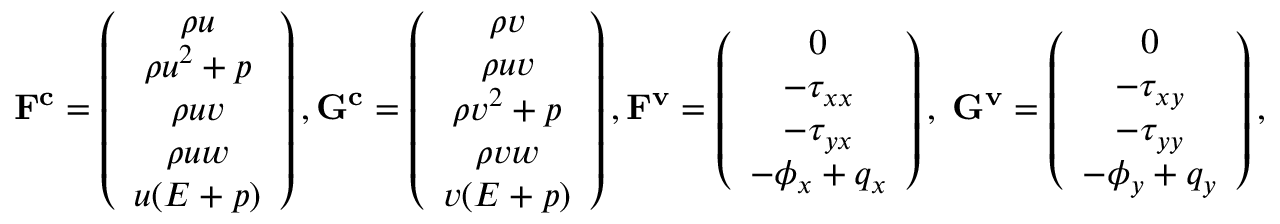<formula> <loc_0><loc_0><loc_500><loc_500>F ^ { c } = \left ( \begin{array} { c } { \rho u } \\ { \rho u ^ { 2 } + p } \\ { \rho u v } \\ { \rho u w } \\ { u ( E + p ) } \end{array} \right ) , G ^ { c } = \left ( \begin{array} { c } { \rho v } \\ { \rho u v } \\ { \rho v ^ { 2 } + p } \\ { \rho v w } \\ { v ( E + p ) } \end{array} \right ) , F ^ { v } = \left ( \begin{array} { c } { 0 } \\ { - \tau _ { x x } } \\ { - \tau _ { y x } } \\ { - \phi _ { x } + q _ { x } } \end{array} \right ) , \, G ^ { v } = \left ( \begin{array} { c } { 0 } \\ { - \tau _ { x y } } \\ { - \tau _ { y y } } \\ { - \phi _ { y } + q _ { y } } \end{array} \right ) ,</formula> 